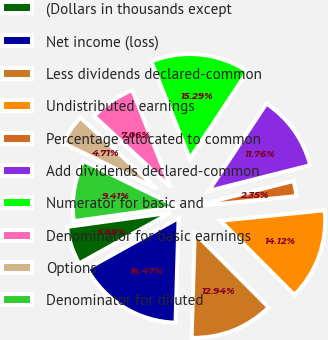Convert chart to OTSL. <chart><loc_0><loc_0><loc_500><loc_500><pie_chart><fcel>(Dollars in thousands except<fcel>Net income (loss)<fcel>Less dividends declared-common<fcel>Undistributed earnings<fcel>Percentage allocated to common<fcel>Add dividends declared-common<fcel>Numerator for basic and<fcel>Denominator for basic earnings<fcel>Options<fcel>Denominator for diluted<nl><fcel>5.88%<fcel>16.47%<fcel>12.94%<fcel>14.12%<fcel>2.35%<fcel>11.76%<fcel>15.29%<fcel>7.06%<fcel>4.71%<fcel>9.41%<nl></chart> 